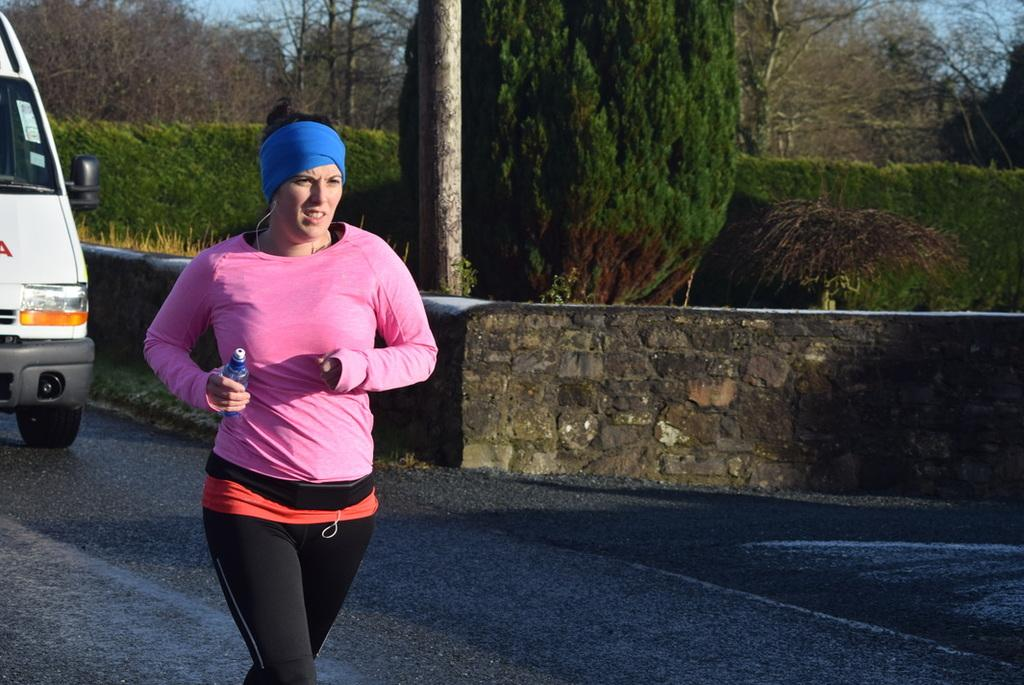What is the main subject of the image? There is a woman in the image. What is the woman doing in the image? The woman is running. What is the woman holding in her hand? The woman is holding a bottle in her hand. What is the woman wearing on her head? The woman is wearing a headband. What type of natural environment can be seen in the image? There are trees visible in the image. What type of man-made structure can be seen in the image? There is a wall in the image. What type of transportation is visible in the image? There is a vehicle on the road in the image. How many houses are visible in the image? There are no houses visible in the image. What number is written on the road in the image? There are no numbers visible on the road in the image. 